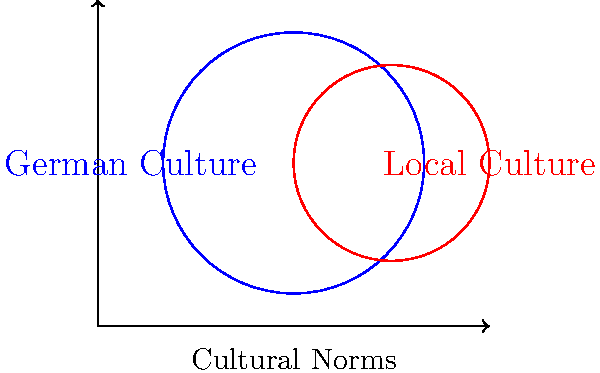As a travel blogger, you're analyzing the overlap between German cultural norms and local customs in a popular tourist destination. The Venn diagram above represents this overlap, where the blue circle (radius 2 units) represents German culture, and the red circle (radius 1.5 units) represents local culture. The centers of the circles are 1.5 units apart. Calculate the area of overlap between the two cultures, which represents shared cultural norms. Round your answer to two decimal places. To solve this problem, we need to calculate the area of overlap between two circles. Let's approach this step-by-step:

1) First, we need to find the distance between the centers of the circles:
   $d = 1.5$ units

2) The radii of the circles are:
   $r_1 = 2$ units (German culture)
   $r_2 = 1.5$ units (Local culture)

3) To find the area of overlap, we use the formula for the area of intersection of two circles:

   $A = r_1^2 \arccos(\frac{d^2 + r_1^2 - r_2^2}{2dr_1}) + r_2^2 \arccos(\frac{d^2 + r_2^2 - r_1^2}{2dr_2}) - \frac{1}{2}\sqrt{(-d+r_1+r_2)(d+r_1-r_2)(d-r_1+r_2)(d+r_1+r_2)}$

4) Let's substitute our values:

   $A = 2^2 \arccos(\frac{1.5^2 + 2^2 - 1.5^2}{2 \cdot 1.5 \cdot 2}) + 1.5^2 \arccos(\frac{1.5^2 + 1.5^2 - 2^2}{2 \cdot 1.5 \cdot 1.5}) - \frac{1}{2}\sqrt{(-1.5+2+1.5)(1.5+2-1.5)(1.5-2+1.5)(1.5+2+1.5)}$

5) Simplify:

   $A = 4 \arccos(0.75) + 2.25 \arccos(0.25) - \frac{1}{2}\sqrt{2 \cdot 2 \cdot 1 \cdot 5}$

6) Calculate:

   $A \approx 4 \cdot 0.7227 + 2.25 \cdot 1.3181 - \frac{1}{2}\sqrt{20}$
   $A \approx 2.8908 + 2.9657 - 2.2361$
   $A \approx 3.6204$

7) Rounding to two decimal places:

   $A \approx 3.62$ square units
Answer: 3.62 square units 